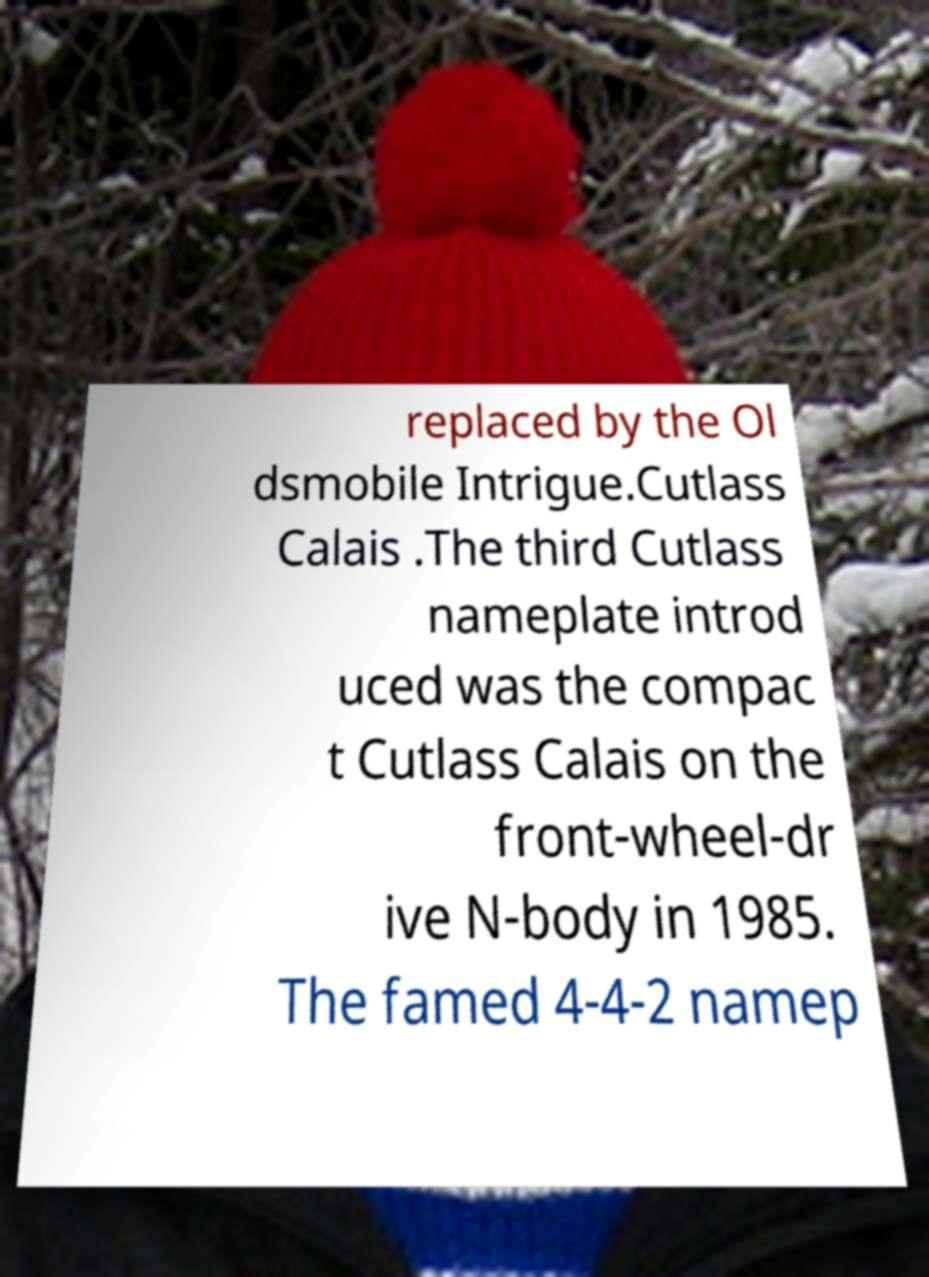Can you read and provide the text displayed in the image?This photo seems to have some interesting text. Can you extract and type it out for me? replaced by the Ol dsmobile Intrigue.Cutlass Calais .The third Cutlass nameplate introd uced was the compac t Cutlass Calais on the front-wheel-dr ive N-body in 1985. The famed 4-4-2 namep 